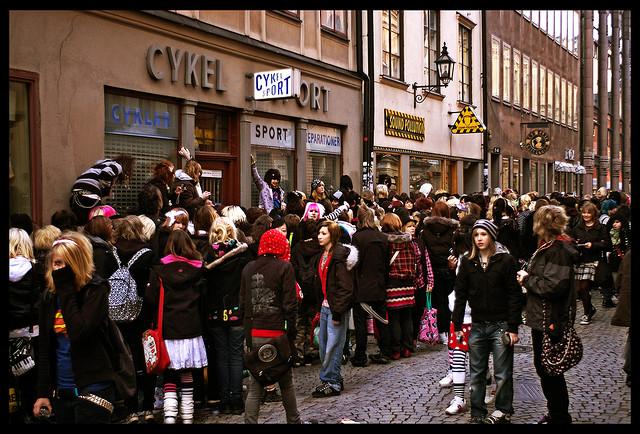What sport does the shop cater to?
Write a very short answer. Bicycling. Is there a motorcycle in the picture?
Quick response, please. No. Is this in America?
Quick response, please. No. Is this a protest?
Short answer required. No. 